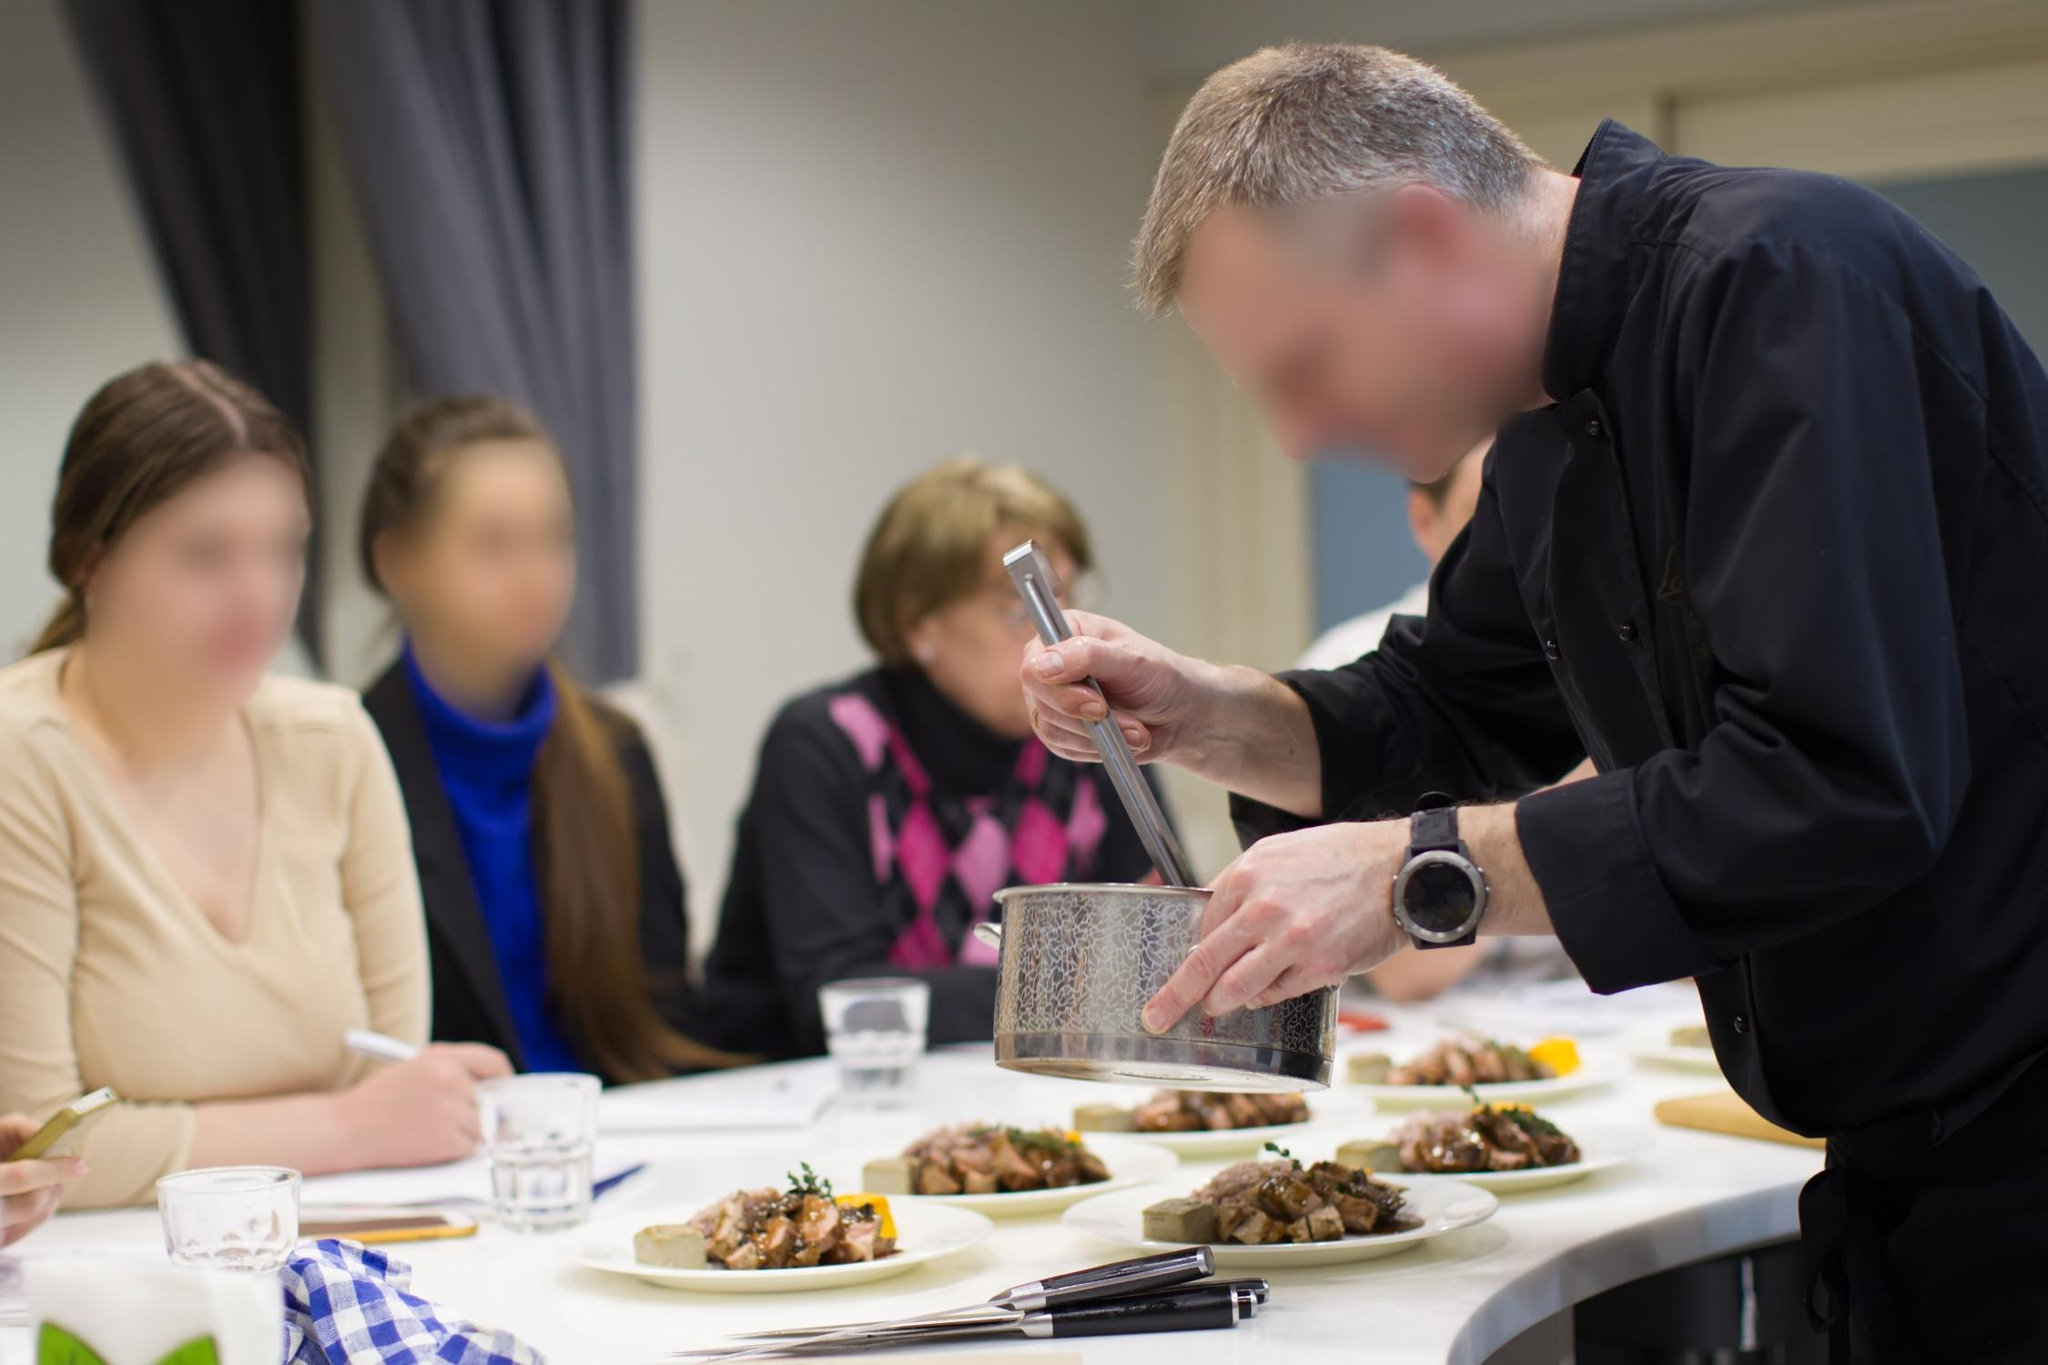Can you narrate a creative, imaginary story based on this image? In a fantastical land where culinary skills were the ultimate source of magic, Chef Alistair stood in his enchanted kitchen, crafting delicacies that possessed mystical properties. Today, he was preparing the famous 'Cheese of Healing,' known to cure ailments and restore vitality. As he grated the magical cheese, it glimmered with a soft, golden light. Three apprentices, each chosen for their unique potential, watched in awe. They had journeyed from distant realms to learn the secrets of this ancient culinary magic. As the aroma of the enchanted dish filled the air, they realized they were witnessing something far more than a simple cooking class—they were part of a tradition that preserved the balance of their world through the power of food. 